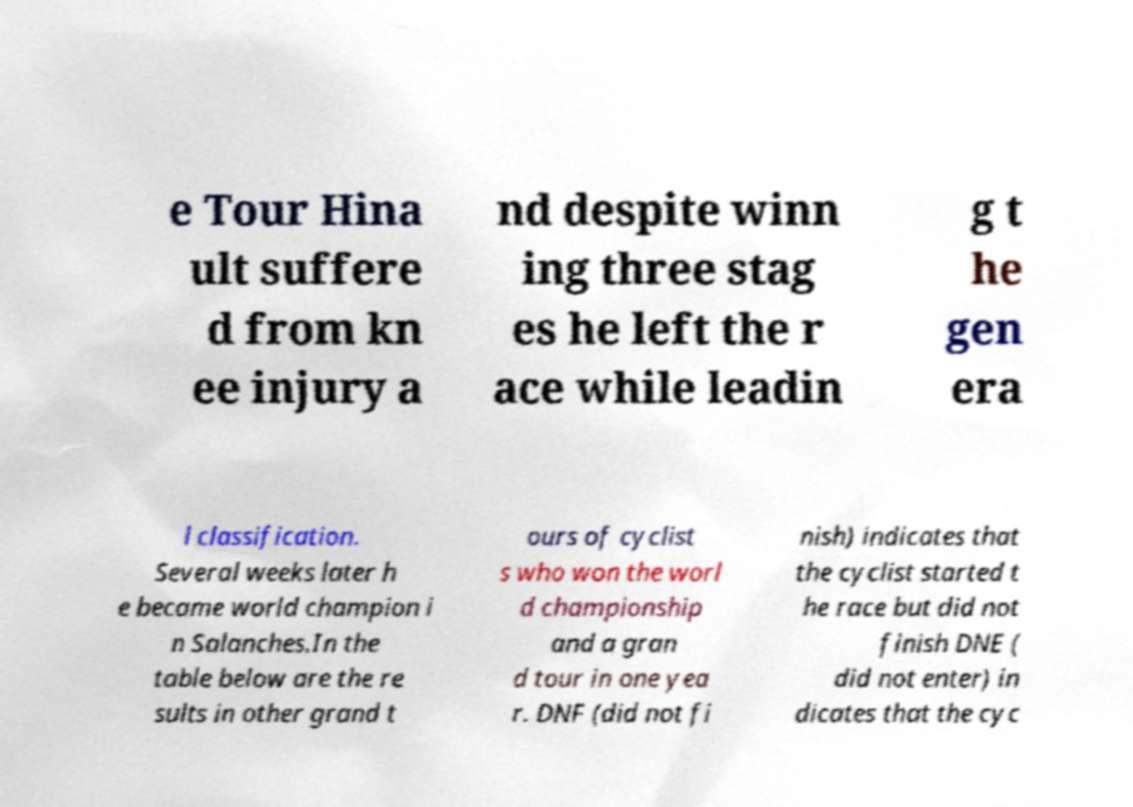Could you assist in decoding the text presented in this image and type it out clearly? e Tour Hina ult suffere d from kn ee injury a nd despite winn ing three stag es he left the r ace while leadin g t he gen era l classification. Several weeks later h e became world champion i n Salanches.In the table below are the re sults in other grand t ours of cyclist s who won the worl d championship and a gran d tour in one yea r. DNF (did not fi nish) indicates that the cyclist started t he race but did not finish DNE ( did not enter) in dicates that the cyc 